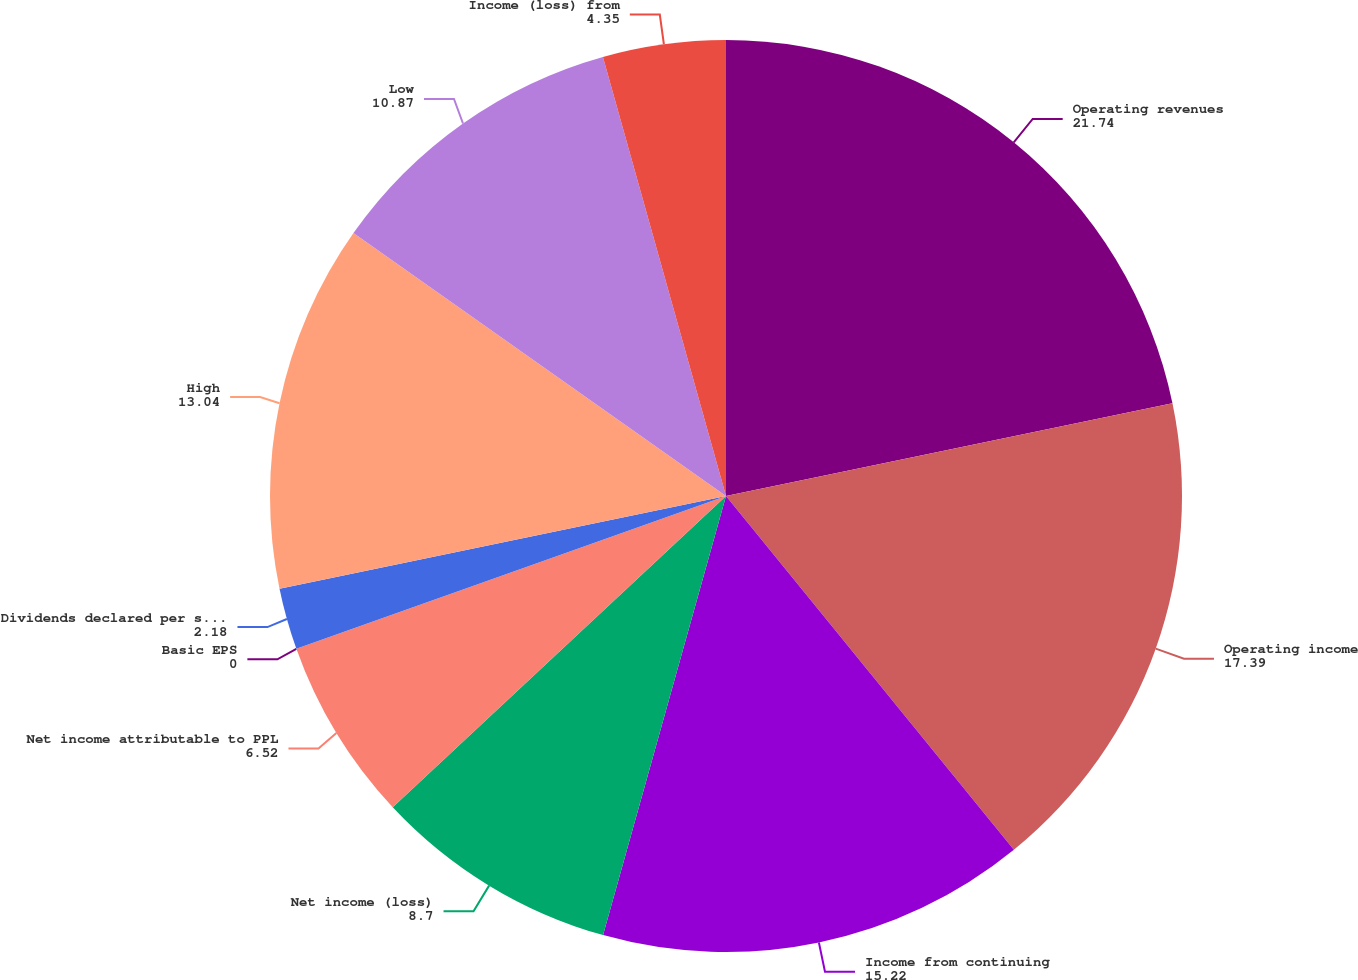Convert chart. <chart><loc_0><loc_0><loc_500><loc_500><pie_chart><fcel>Operating revenues<fcel>Operating income<fcel>Income from continuing<fcel>Net income (loss)<fcel>Net income attributable to PPL<fcel>Basic EPS<fcel>Dividends declared per share<fcel>High<fcel>Low<fcel>Income (loss) from<nl><fcel>21.74%<fcel>17.39%<fcel>15.22%<fcel>8.7%<fcel>6.52%<fcel>0.0%<fcel>2.18%<fcel>13.04%<fcel>10.87%<fcel>4.35%<nl></chart> 